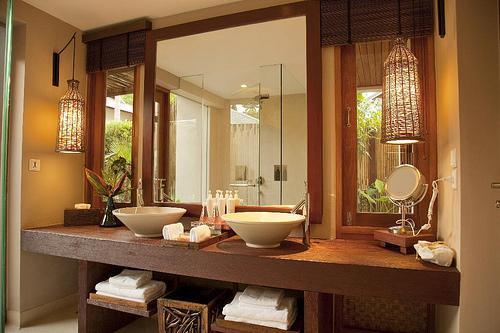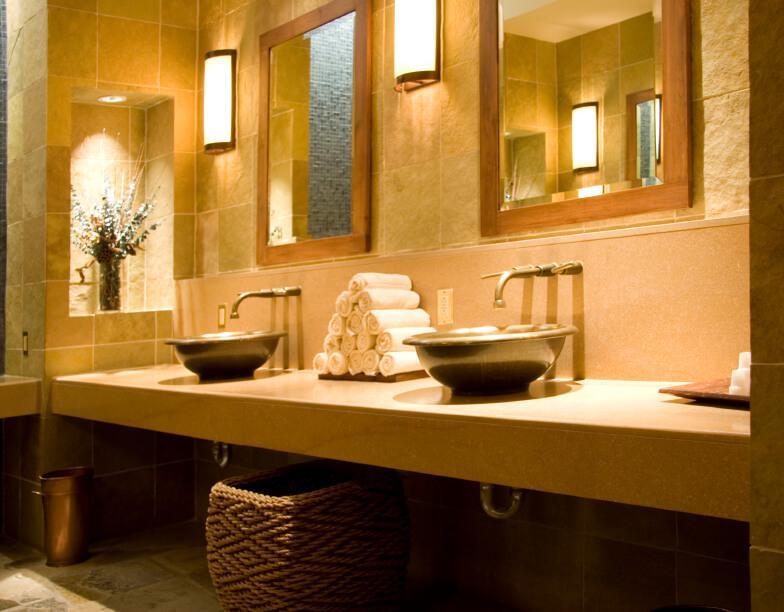The first image is the image on the left, the second image is the image on the right. For the images displayed, is the sentence "In one image two vessel sinks are placed on a vanity with two stacks of white towels on a shelf below." factually correct? Answer yes or no. Yes. The first image is the image on the left, the second image is the image on the right. Evaluate the accuracy of this statement regarding the images: "Left and right images each show one long counter with two separate sinks displayed at similar angles, and the counter on the right has at least one woven basket under it.". Is it true? Answer yes or no. Yes. 